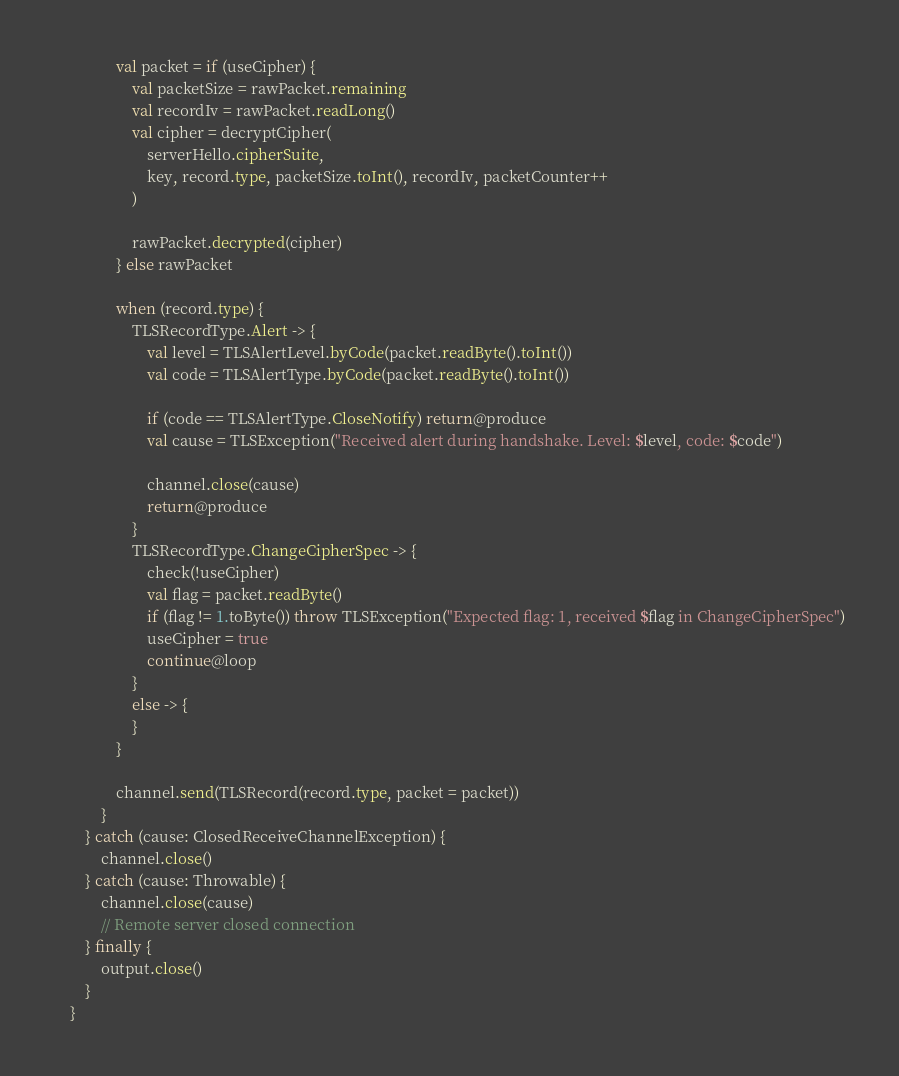Convert code to text. <code><loc_0><loc_0><loc_500><loc_500><_Kotlin_>                val packet = if (useCipher) {
                    val packetSize = rawPacket.remaining
                    val recordIv = rawPacket.readLong()
                    val cipher = decryptCipher(
                        serverHello.cipherSuite,
                        key, record.type, packetSize.toInt(), recordIv, packetCounter++
                    )

                    rawPacket.decrypted(cipher)
                } else rawPacket

                when (record.type) {
                    TLSRecordType.Alert -> {
                        val level = TLSAlertLevel.byCode(packet.readByte().toInt())
                        val code = TLSAlertType.byCode(packet.readByte().toInt())

                        if (code == TLSAlertType.CloseNotify) return@produce
                        val cause = TLSException("Received alert during handshake. Level: $level, code: $code")

                        channel.close(cause)
                        return@produce
                    }
                    TLSRecordType.ChangeCipherSpec -> {
                        check(!useCipher)
                        val flag = packet.readByte()
                        if (flag != 1.toByte()) throw TLSException("Expected flag: 1, received $flag in ChangeCipherSpec")
                        useCipher = true
                        continue@loop
                    }
                    else -> {
                    }
                }

                channel.send(TLSRecord(record.type, packet = packet))
            }
        } catch (cause: ClosedReceiveChannelException) {
            channel.close()
        } catch (cause: Throwable) {
            channel.close(cause)
            // Remote server closed connection
        } finally {
            output.close()
        }
    }
</code> 